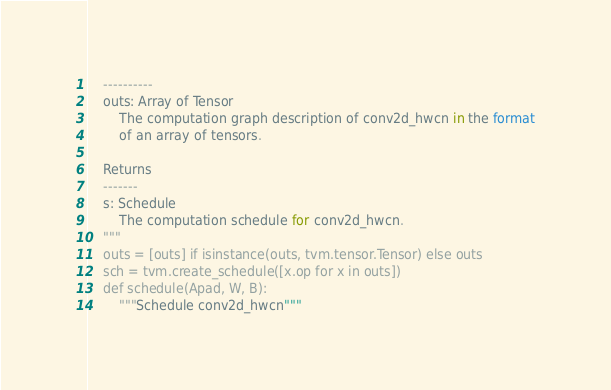Convert code to text. <code><loc_0><loc_0><loc_500><loc_500><_Python_>    ----------
    outs: Array of Tensor
        The computation graph description of conv2d_hwcn in the format
        of an array of tensors.

    Returns
    -------
    s: Schedule
        The computation schedule for conv2d_hwcn.
    """
    outs = [outs] if isinstance(outs, tvm.tensor.Tensor) else outs
    sch = tvm.create_schedule([x.op for x in outs])
    def schedule(Apad, W, B):
        """Schedule conv2d_hwcn"""</code> 